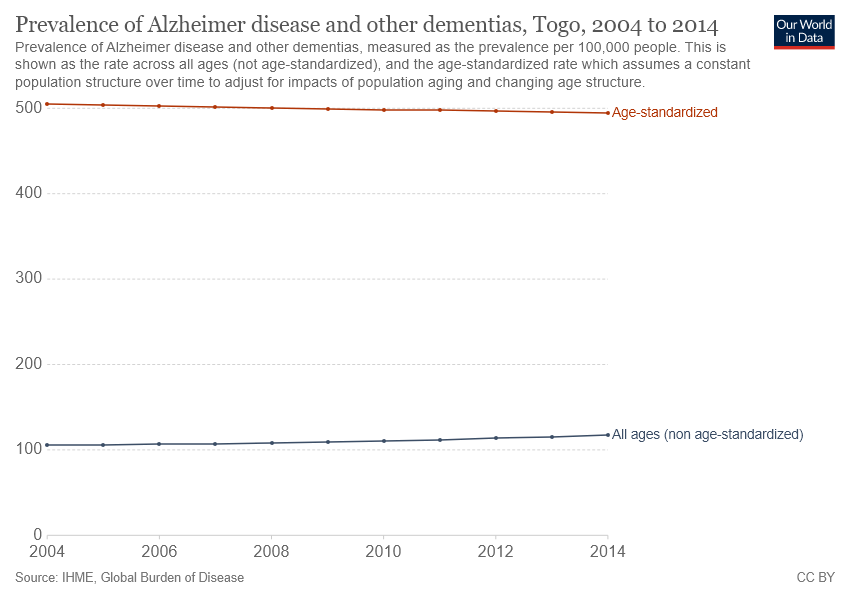Draw attention to some important aspects in this diagram. The population that had a higher prevalence of Alzheimer's disease over the years, when adjusted for age, was [insert population here]. In 2014, the peak year of "all ages" was reached. 